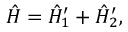<formula> <loc_0><loc_0><loc_500><loc_500>\begin{array} { r } { \hat { H } = \hat { H } _ { 1 } ^ { \prime } + \hat { H } _ { 2 } ^ { \prime } , } \end{array}</formula> 